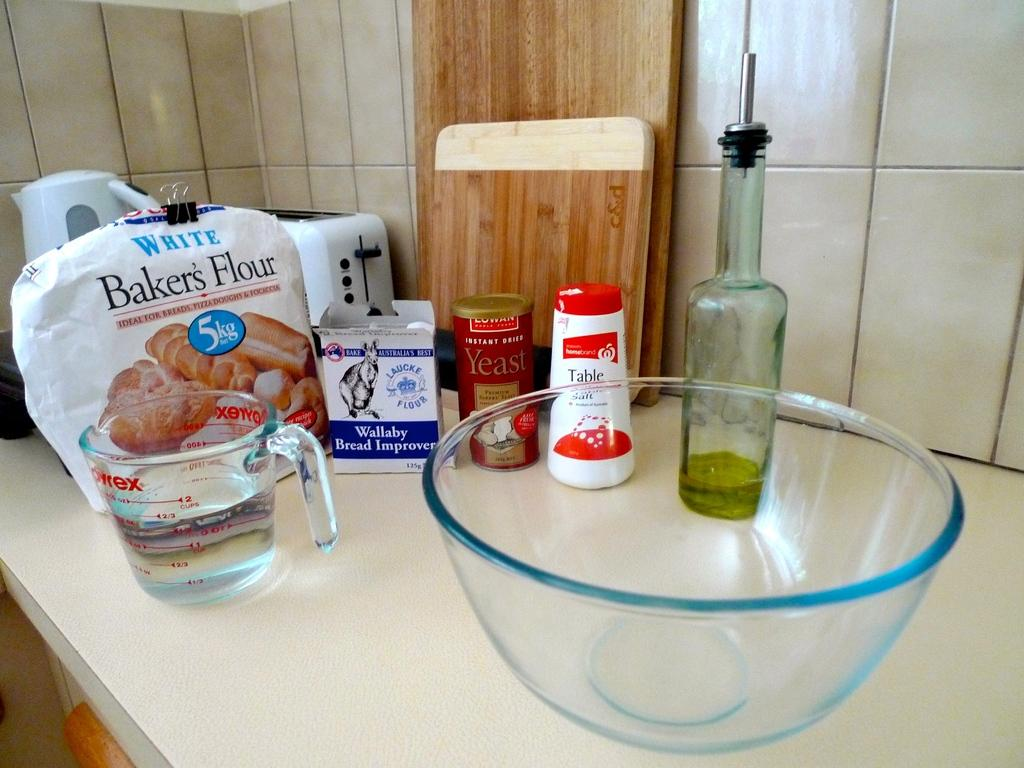Provide a one-sentence caption for the provided image. A mixing bowl is on a counter with bakers flour and Wallaby bread improver. 